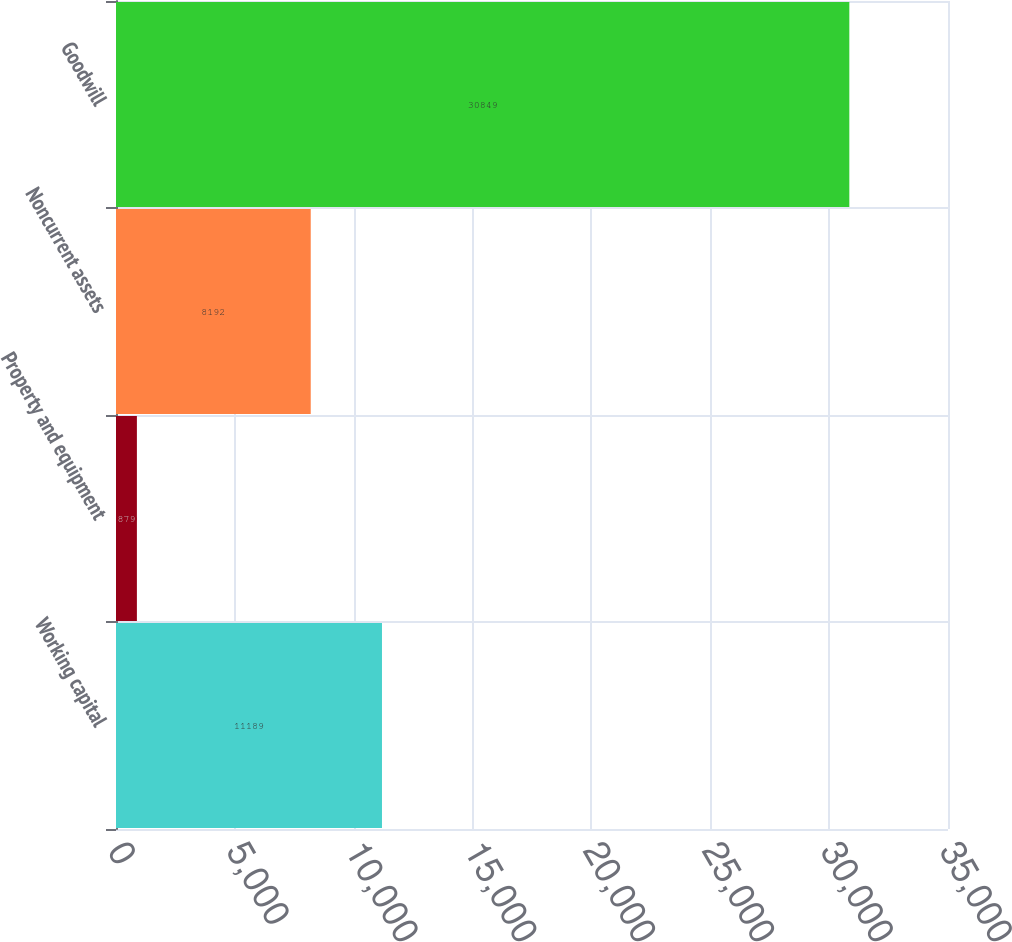Convert chart. <chart><loc_0><loc_0><loc_500><loc_500><bar_chart><fcel>Working capital<fcel>Property and equipment<fcel>Noncurrent assets<fcel>Goodwill<nl><fcel>11189<fcel>879<fcel>8192<fcel>30849<nl></chart> 